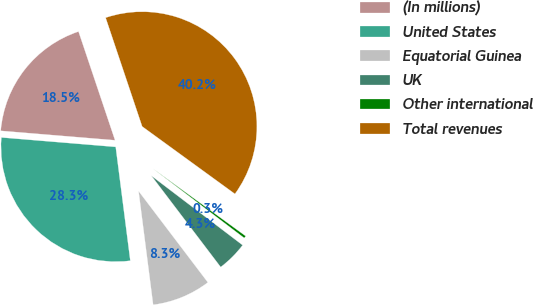Convert chart. <chart><loc_0><loc_0><loc_500><loc_500><pie_chart><fcel>(In millions)<fcel>United States<fcel>Equatorial Guinea<fcel>UK<fcel>Other international<fcel>Total revenues<nl><fcel>18.53%<fcel>28.34%<fcel>8.3%<fcel>4.32%<fcel>0.34%<fcel>40.16%<nl></chart> 